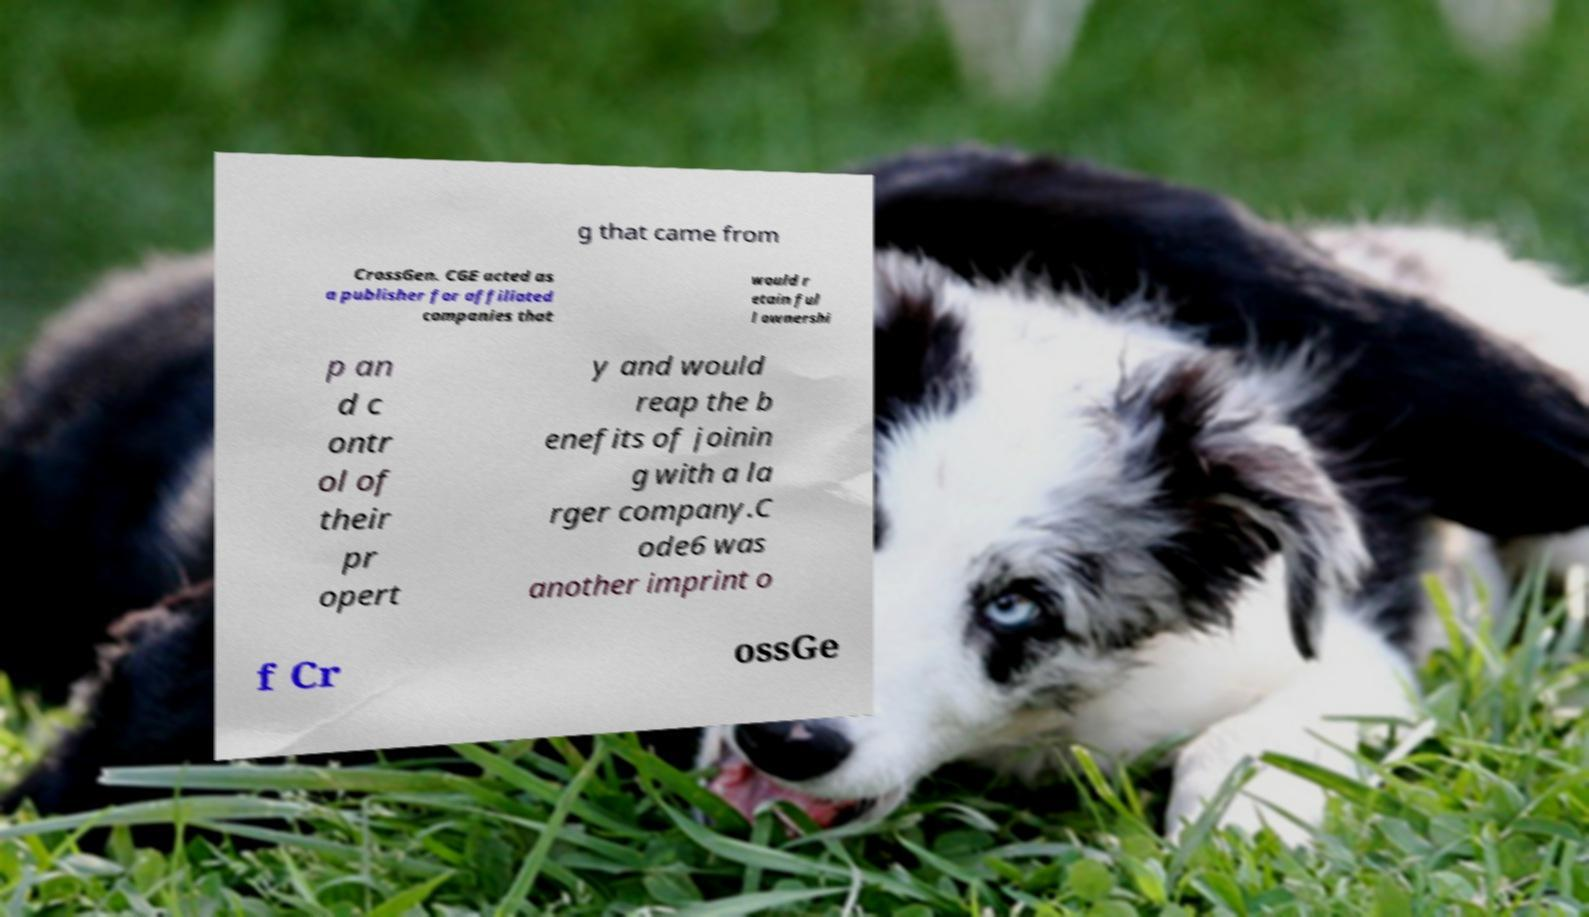Please identify and transcribe the text found in this image. g that came from CrossGen. CGE acted as a publisher for affiliated companies that would r etain ful l ownershi p an d c ontr ol of their pr opert y and would reap the b enefits of joinin g with a la rger company.C ode6 was another imprint o f Cr ossGe 